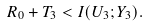Convert formula to latex. <formula><loc_0><loc_0><loc_500><loc_500>R _ { 0 } + T _ { 3 } < I ( U _ { 3 } ; Y _ { 3 } ) .</formula> 